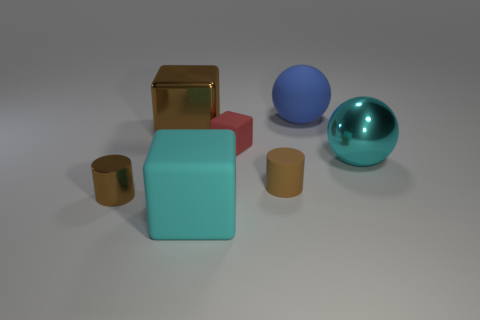Does the cyan ball have the same material as the red block?
Make the answer very short. No. The other large object that is the same shape as the large cyan metal object is what color?
Make the answer very short. Blue. There is a large cube in front of the small brown metallic cylinder; is its color the same as the tiny matte block?
Give a very brief answer. No. The small rubber object that is the same color as the metal cube is what shape?
Provide a short and direct response. Cylinder. How many big brown cubes are the same material as the tiny red object?
Offer a terse response. 0. What number of small rubber things are on the right side of the brown matte cylinder?
Make the answer very short. 0. What is the size of the cyan cube?
Offer a terse response. Large. There is a shiny sphere that is the same size as the brown block; what is its color?
Give a very brief answer. Cyan. Are there any other shiny cubes that have the same color as the large metallic cube?
Ensure brevity in your answer.  No. What is the red thing made of?
Provide a succinct answer. Rubber. 